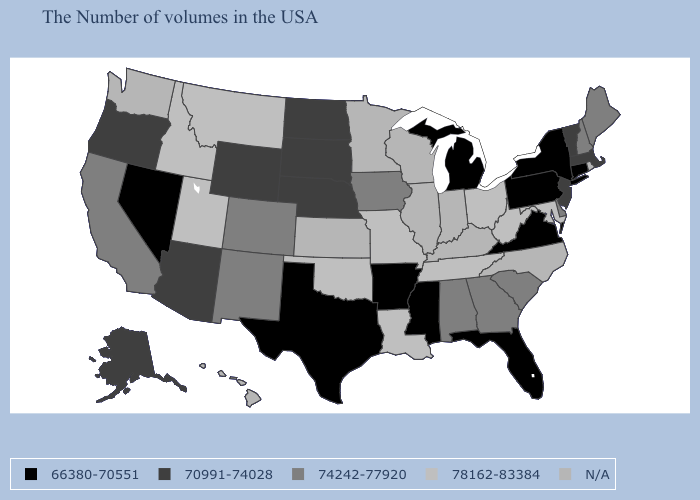Name the states that have a value in the range 74242-77920?
Short answer required. Maine, New Hampshire, Delaware, South Carolina, Georgia, Alabama, Iowa, Colorado, New Mexico, California. Does Connecticut have the lowest value in the Northeast?
Short answer required. Yes. What is the value of Wisconsin?
Be succinct. N/A. Name the states that have a value in the range N/A?
Answer briefly. Rhode Island, North Carolina, Kentucky, Indiana, Wisconsin, Illinois, Minnesota, Kansas, Washington, Hawaii. Which states have the lowest value in the West?
Answer briefly. Nevada. What is the value of Oregon?
Give a very brief answer. 70991-74028. What is the lowest value in states that border Mississippi?
Be succinct. 66380-70551. Name the states that have a value in the range N/A?
Keep it brief. Rhode Island, North Carolina, Kentucky, Indiana, Wisconsin, Illinois, Minnesota, Kansas, Washington, Hawaii. Does Mississippi have the lowest value in the South?
Keep it brief. Yes. Name the states that have a value in the range 78162-83384?
Write a very short answer. Maryland, West Virginia, Ohio, Tennessee, Louisiana, Missouri, Oklahoma, Utah, Montana, Idaho. What is the lowest value in the MidWest?
Give a very brief answer. 66380-70551. What is the value of Colorado?
Give a very brief answer. 74242-77920. Does Oklahoma have the lowest value in the South?
Answer briefly. No. Name the states that have a value in the range 78162-83384?
Keep it brief. Maryland, West Virginia, Ohio, Tennessee, Louisiana, Missouri, Oklahoma, Utah, Montana, Idaho. 